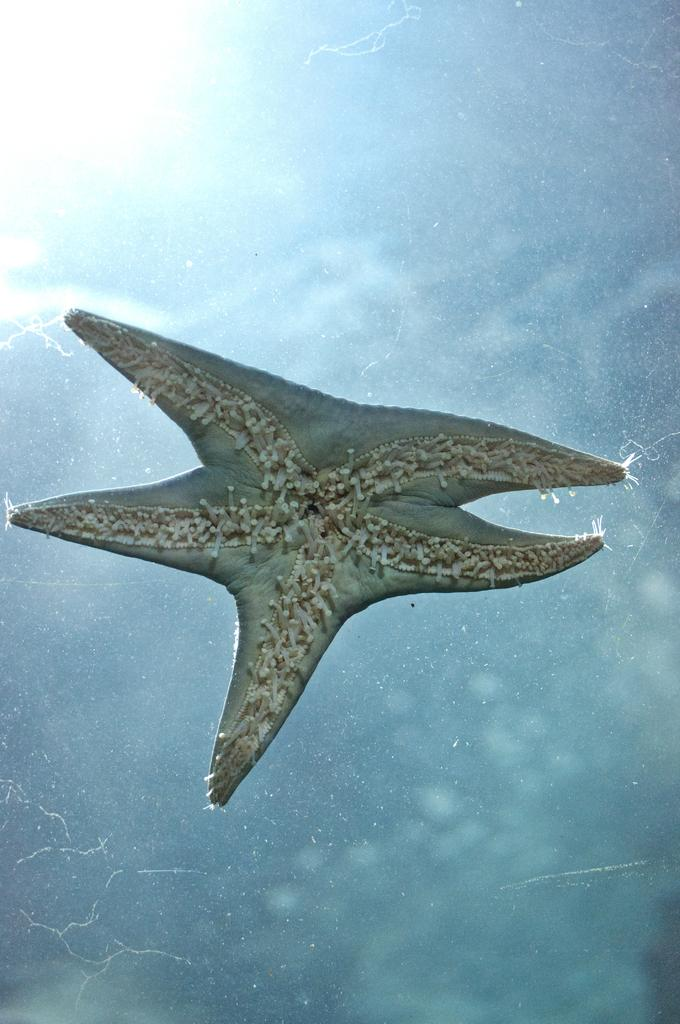What is the main subject in the center of the image? There is a starfish in the center of the image. What color is the area surrounding the starfish? The area around the starfish is light blue in color. What type of club is located near the seashore in the image? There is no club or seashore present in the image; it only features a starfish in a light blue area. 